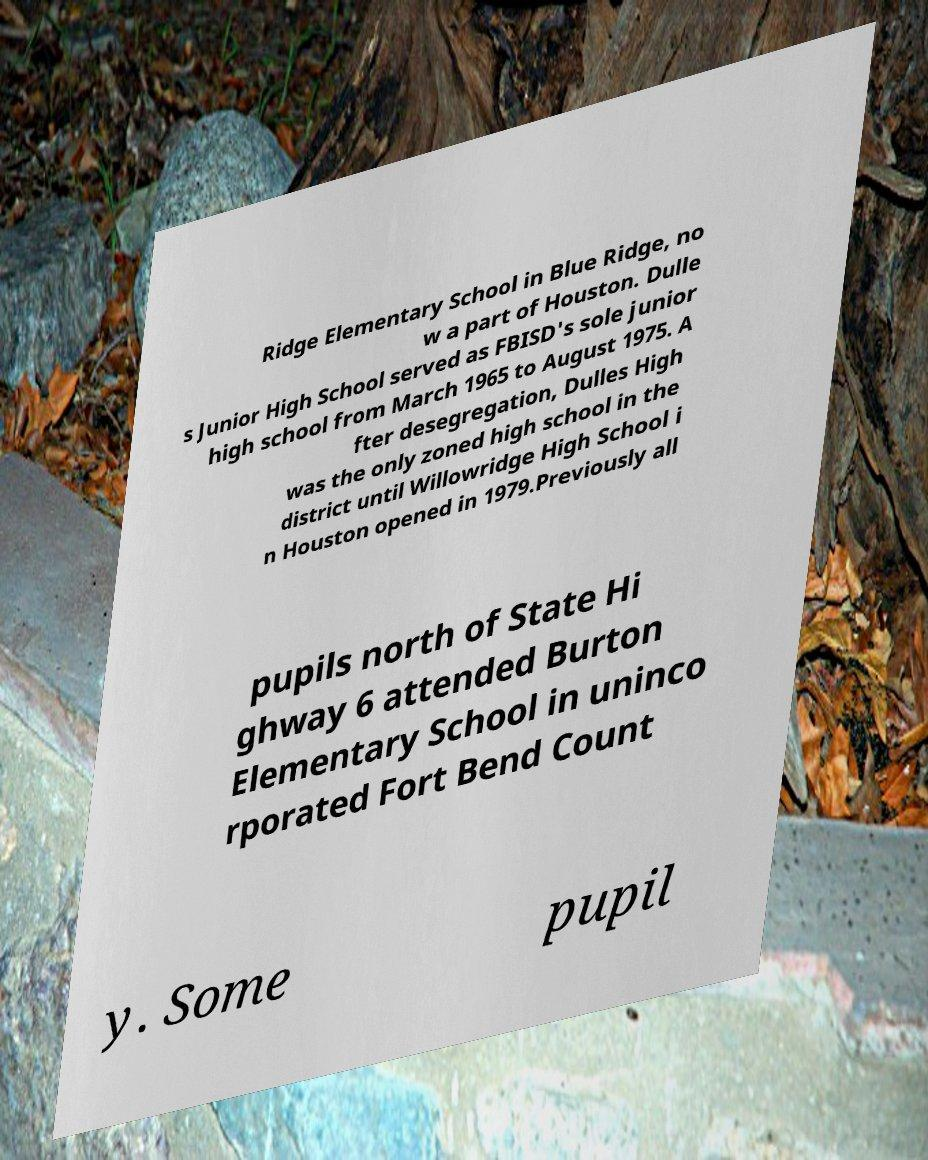I need the written content from this picture converted into text. Can you do that? Ridge Elementary School in Blue Ridge, no w a part of Houston. Dulle s Junior High School served as FBISD's sole junior high school from March 1965 to August 1975. A fter desegregation, Dulles High was the only zoned high school in the district until Willowridge High School i n Houston opened in 1979.Previously all pupils north of State Hi ghway 6 attended Burton Elementary School in uninco rporated Fort Bend Count y. Some pupil 